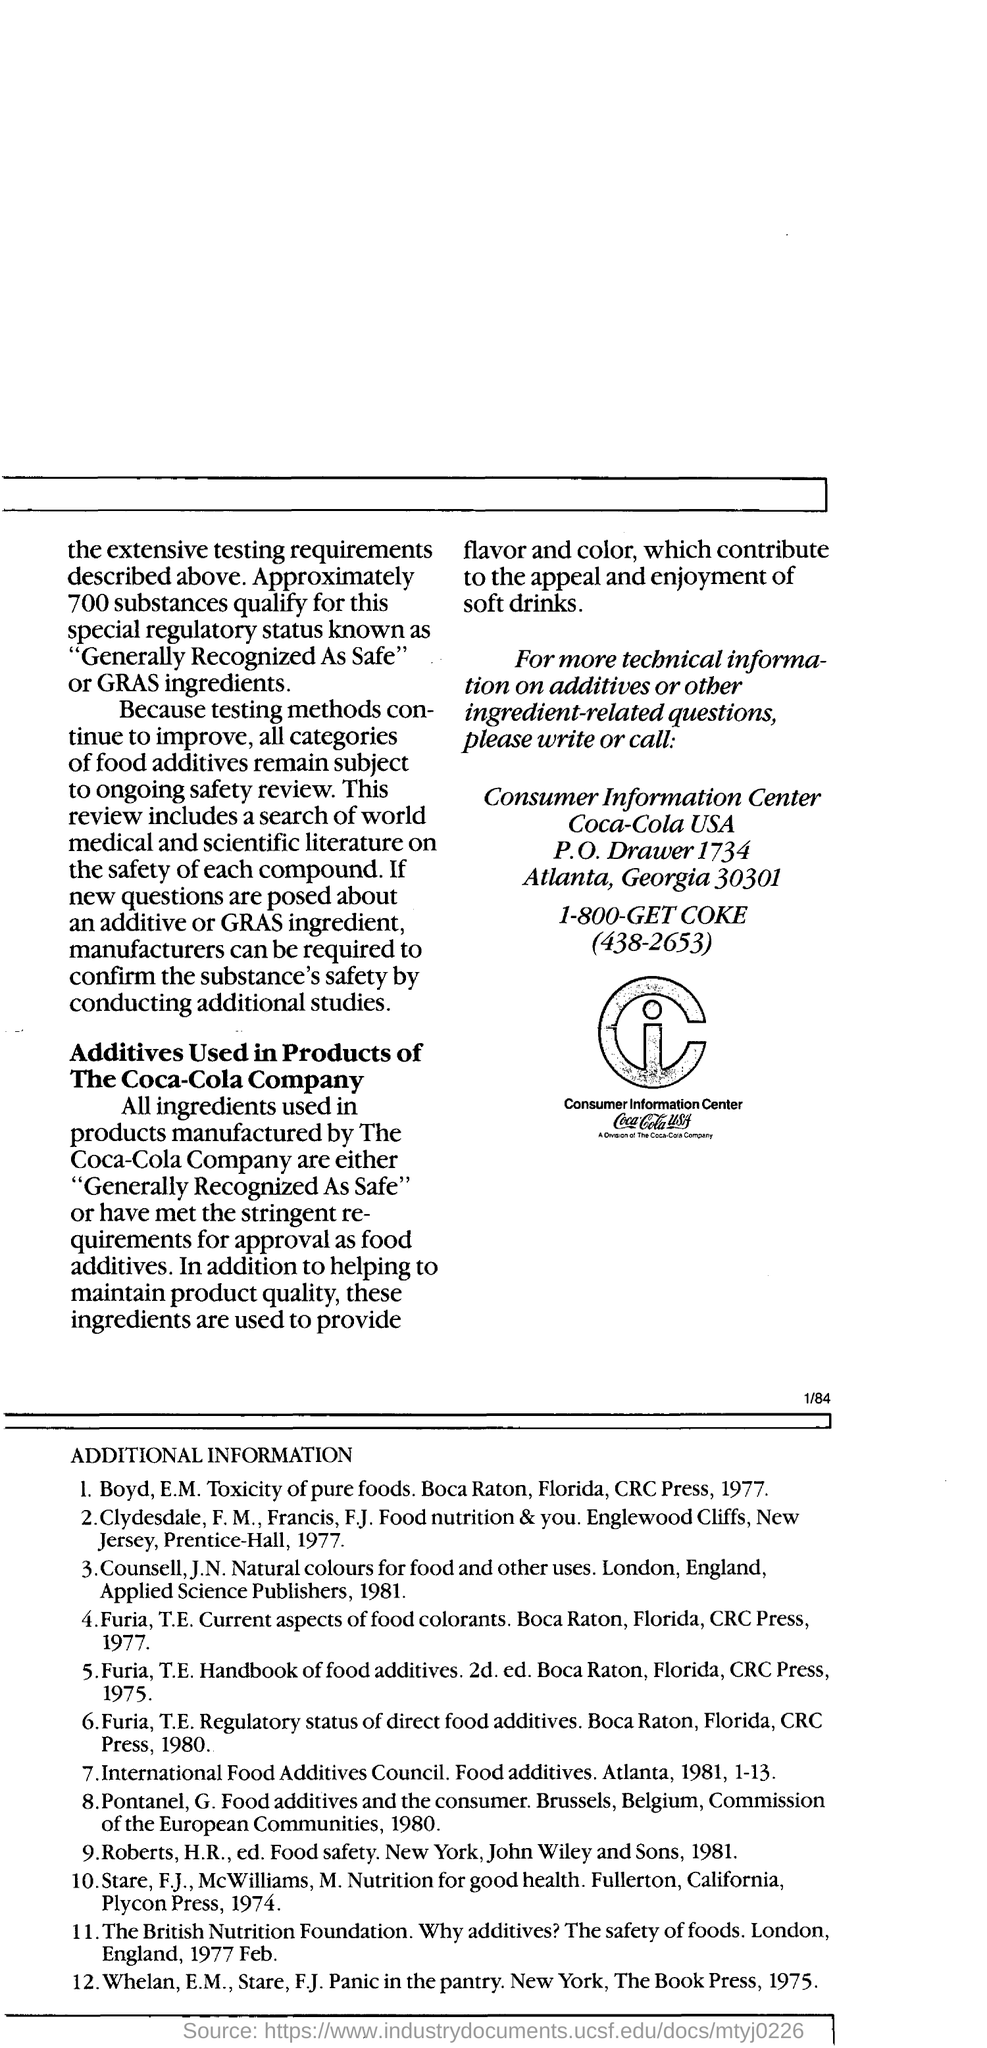Give some essential details in this illustration. The Consumer Information Center is located in the state of Georgia. The location of consumer information for Coca-Cola is in the United States. 